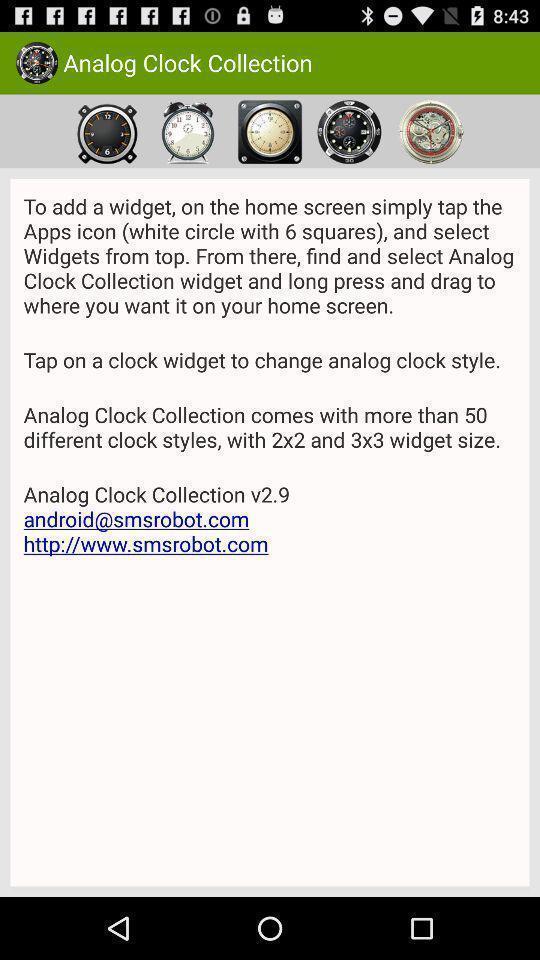What details can you identify in this image? Screen displaying images of analog clocks. 